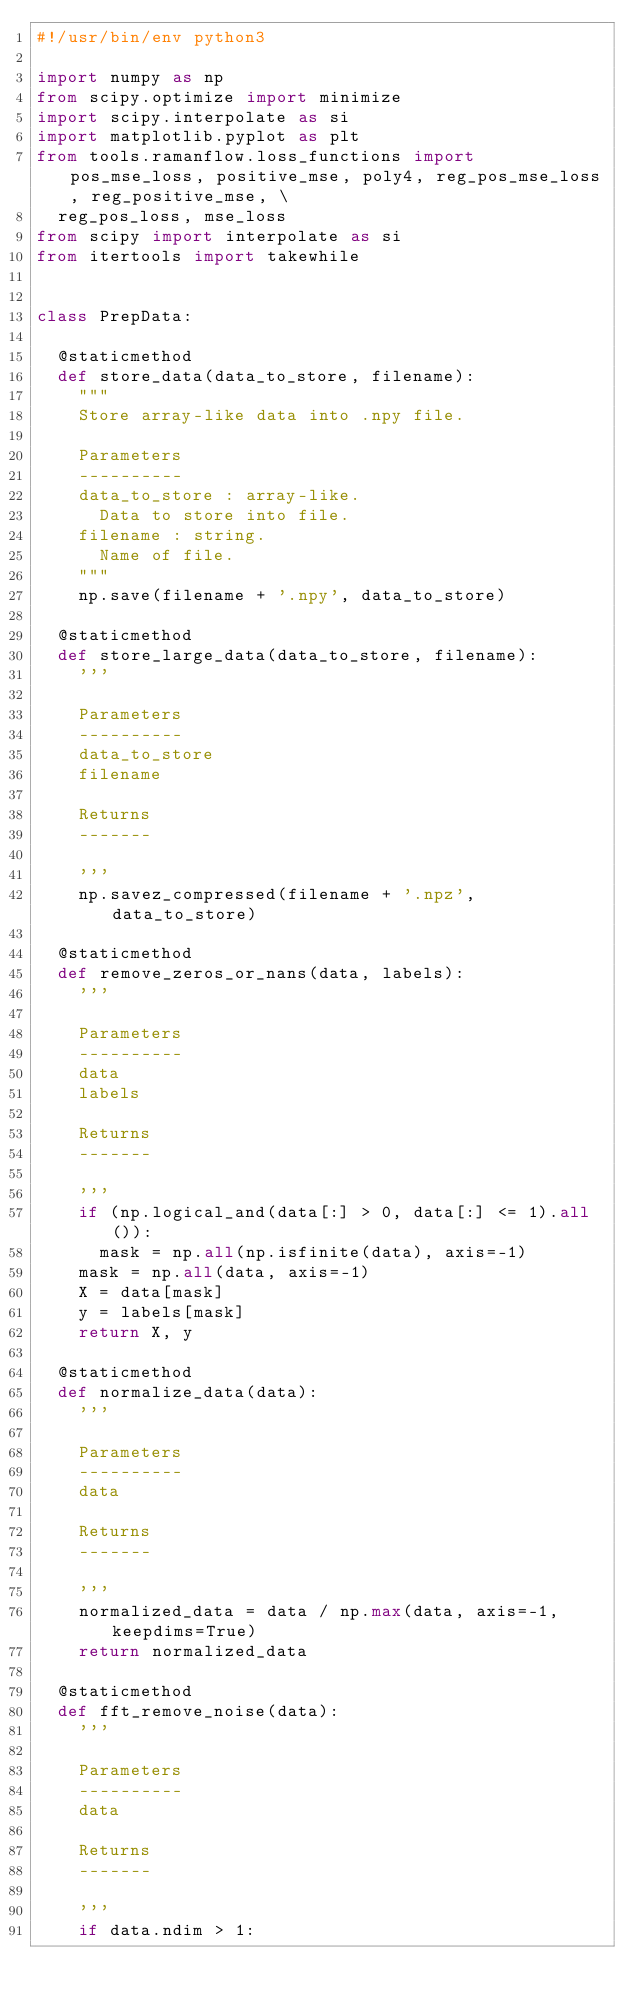<code> <loc_0><loc_0><loc_500><loc_500><_Python_>#!/usr/bin/env python3

import numpy as np
from scipy.optimize import minimize
import scipy.interpolate as si
import matplotlib.pyplot as plt
from tools.ramanflow.loss_functions import pos_mse_loss, positive_mse, poly4, reg_pos_mse_loss, reg_positive_mse, \
	reg_pos_loss, mse_loss
from scipy import interpolate as si
from itertools import takewhile


class PrepData:
	
	@staticmethod
	def store_data(data_to_store, filename):
		"""
		Store array-like data into .npy file.
		
		Parameters
		----------
		data_to_store : array-like.
			Data to store into file.
		filename : string.
			Name of file.
		"""
		np.save(filename + '.npy', data_to_store)
		
	@staticmethod
	def store_large_data(data_to_store, filename):
		'''

		Parameters
		----------
		data_to_store
		filename

		Returns
		-------

		'''
		np.savez_compressed(filename + '.npz', data_to_store)
		
	@staticmethod
	def remove_zeros_or_nans(data, labels):
		'''

		Parameters
		----------
		data
		labels

		Returns
		-------

		'''
		if (np.logical_and(data[:] > 0, data[:] <= 1).all()):
			mask = np.all(np.isfinite(data), axis=-1)
		mask = np.all(data, axis=-1)
		X = data[mask]
		y = labels[mask]
		return X, y
	
	@staticmethod
	def normalize_data(data):
		'''

		Parameters
		----------
		data

		Returns
		-------

		'''
		normalized_data = data / np.max(data, axis=-1, keepdims=True)
		return normalized_data
	
	@staticmethod
	def fft_remove_noise(data):
		'''

		Parameters
		----------
		data

		Returns
		-------

		'''
		if data.ndim > 1:</code> 